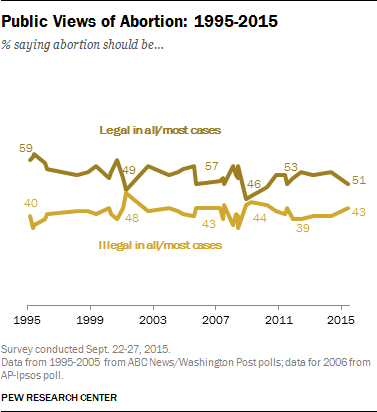Highlight a few significant elements in this photo. We propose using the highest value of "Legal in all/most cases" and the rightmost value of "Illegal in all/most cases" and multiplying the result by 2 in order to more accurately represent the sentiment of the data. In 2011, 53% of public views held that abortion was legal in all or most cases. 